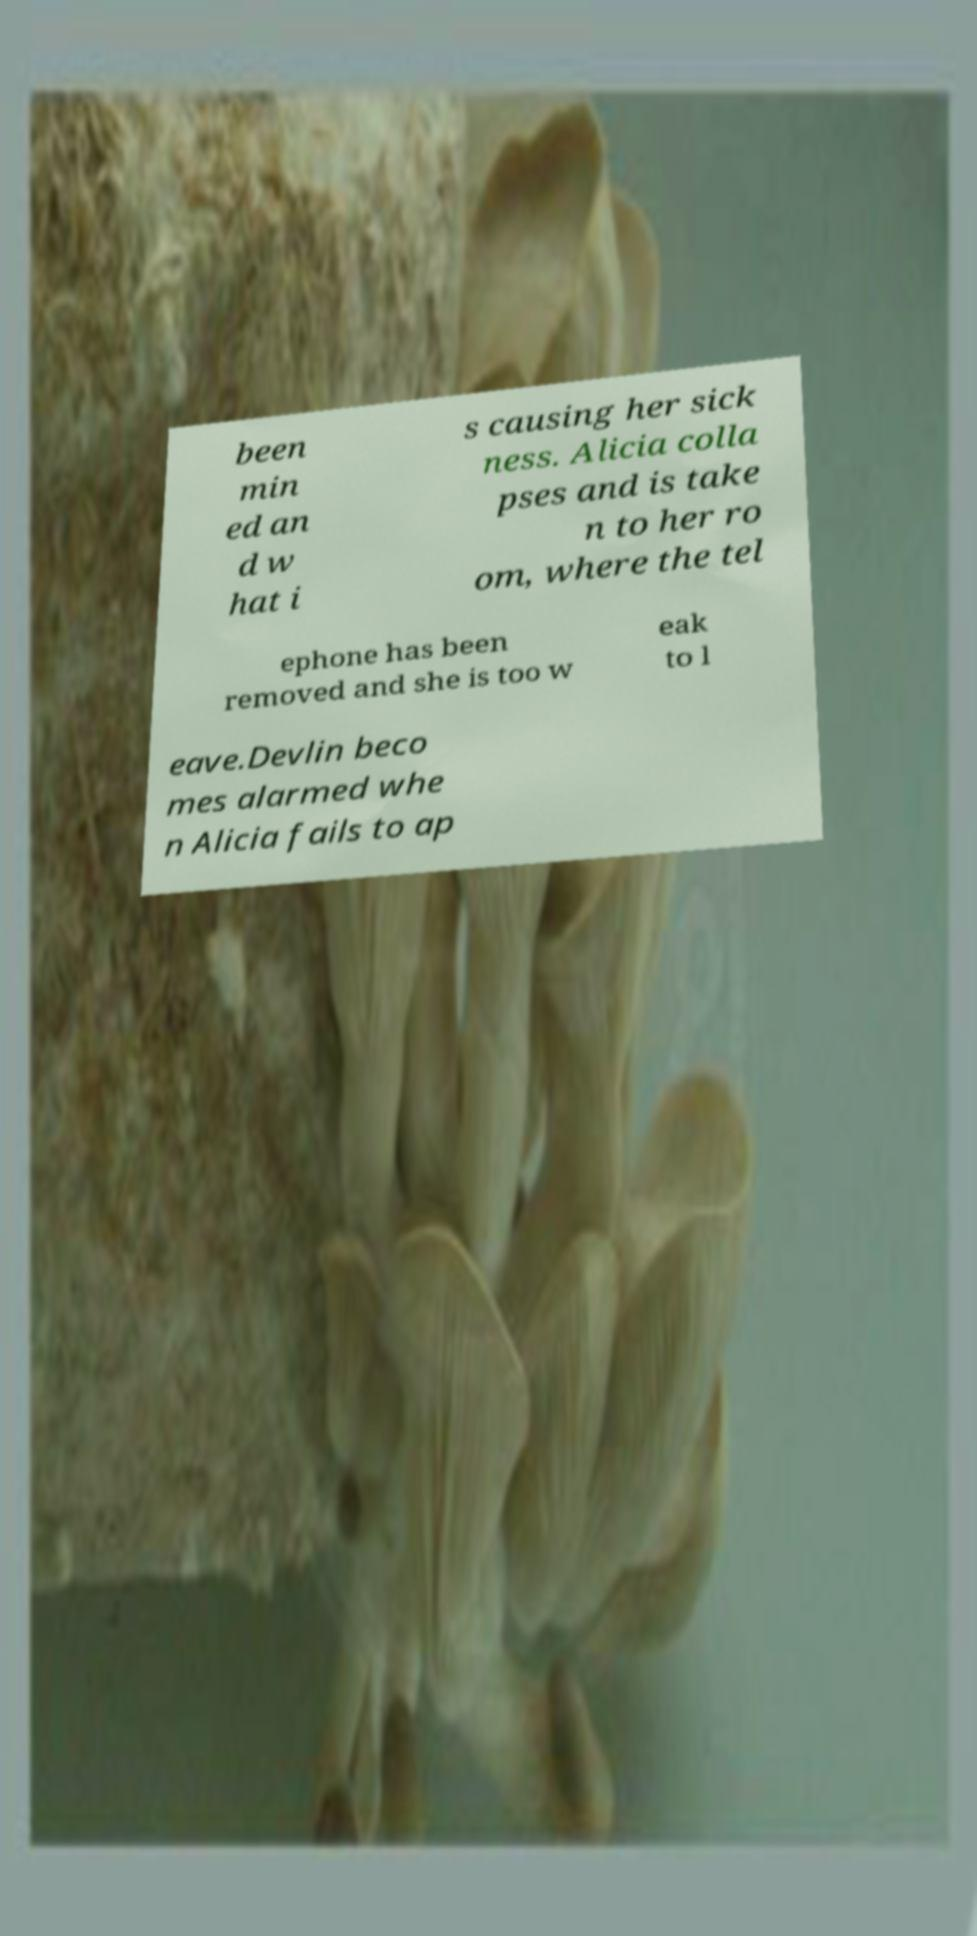Please read and relay the text visible in this image. What does it say? been min ed an d w hat i s causing her sick ness. Alicia colla pses and is take n to her ro om, where the tel ephone has been removed and she is too w eak to l eave.Devlin beco mes alarmed whe n Alicia fails to ap 